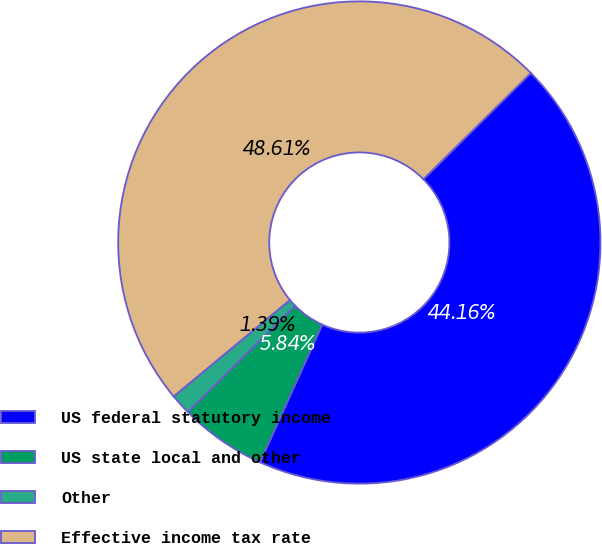Convert chart to OTSL. <chart><loc_0><loc_0><loc_500><loc_500><pie_chart><fcel>US federal statutory income<fcel>US state local and other<fcel>Other<fcel>Effective income tax rate<nl><fcel>44.16%<fcel>5.84%<fcel>1.39%<fcel>48.61%<nl></chart> 